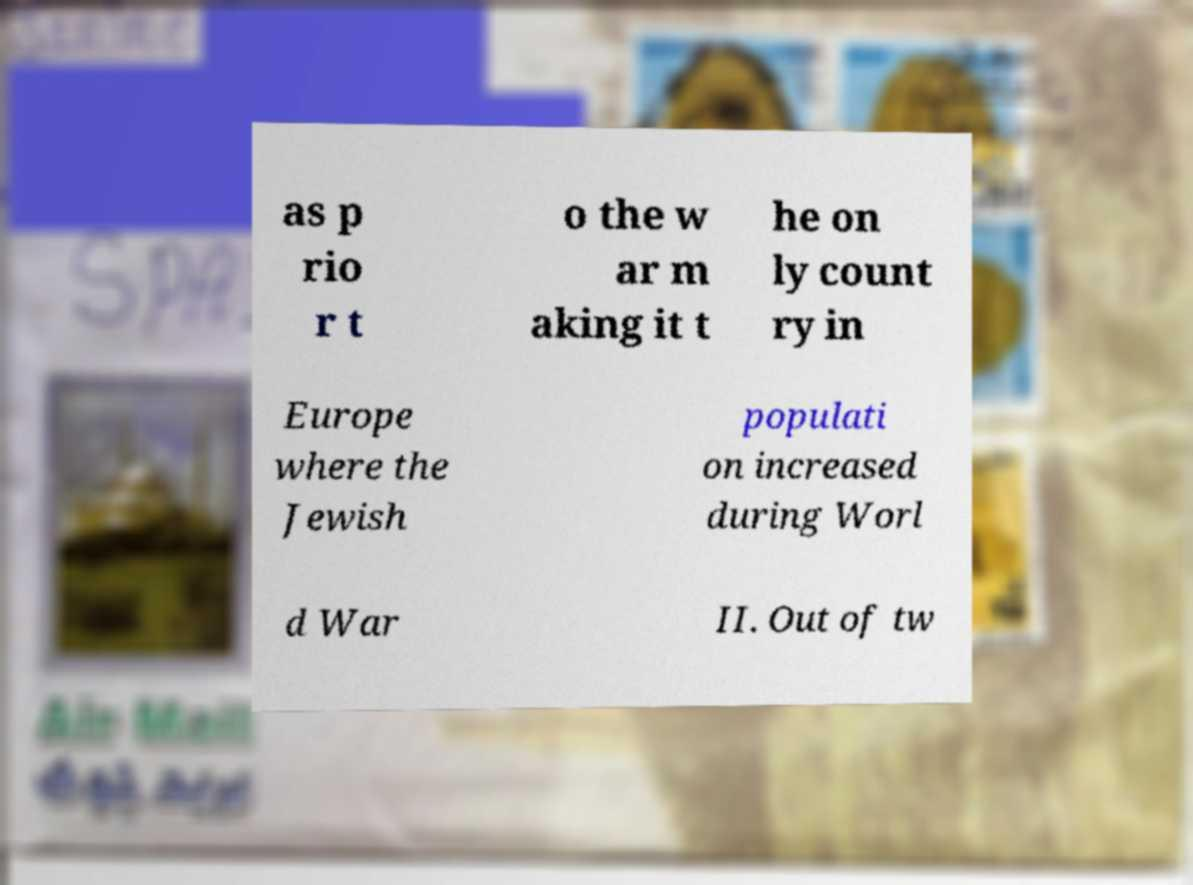Please identify and transcribe the text found in this image. as p rio r t o the w ar m aking it t he on ly count ry in Europe where the Jewish populati on increased during Worl d War II. Out of tw 